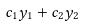<formula> <loc_0><loc_0><loc_500><loc_500>c _ { 1 } y _ { 1 } + c _ { 2 } y _ { 2 }</formula> 